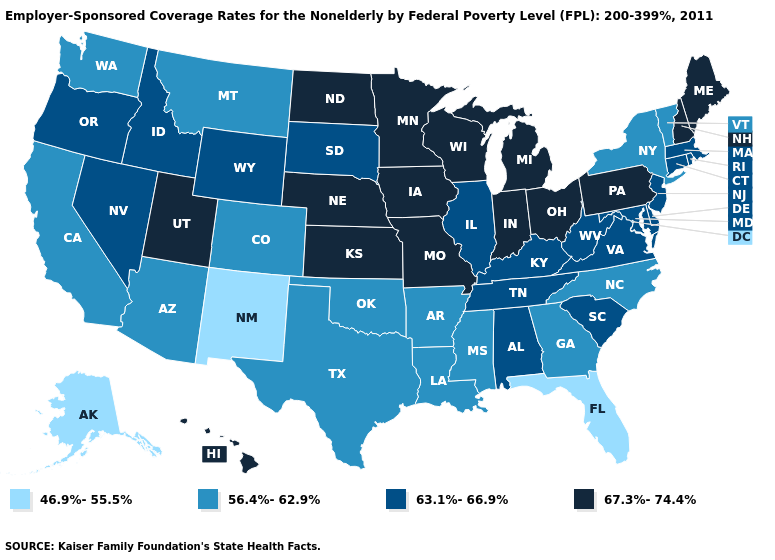Name the states that have a value in the range 63.1%-66.9%?
Be succinct. Alabama, Connecticut, Delaware, Idaho, Illinois, Kentucky, Maryland, Massachusetts, Nevada, New Jersey, Oregon, Rhode Island, South Carolina, South Dakota, Tennessee, Virginia, West Virginia, Wyoming. What is the value of Idaho?
Be succinct. 63.1%-66.9%. Name the states that have a value in the range 56.4%-62.9%?
Give a very brief answer. Arizona, Arkansas, California, Colorado, Georgia, Louisiana, Mississippi, Montana, New York, North Carolina, Oklahoma, Texas, Vermont, Washington. Does Arkansas have a higher value than Florida?
Quick response, please. Yes. What is the lowest value in the Northeast?
Quick response, please. 56.4%-62.9%. Does the first symbol in the legend represent the smallest category?
Give a very brief answer. Yes. Does New Jersey have the lowest value in the Northeast?
Answer briefly. No. How many symbols are there in the legend?
Give a very brief answer. 4. Among the states that border Maryland , does Pennsylvania have the highest value?
Be succinct. Yes. What is the lowest value in the Northeast?
Write a very short answer. 56.4%-62.9%. Among the states that border Montana , does North Dakota have the lowest value?
Keep it brief. No. Does Ohio have the highest value in the USA?
Be succinct. Yes. Among the states that border New York , does Vermont have the lowest value?
Quick response, please. Yes. What is the value of Montana?
Keep it brief. 56.4%-62.9%. Which states have the lowest value in the West?
Write a very short answer. Alaska, New Mexico. 